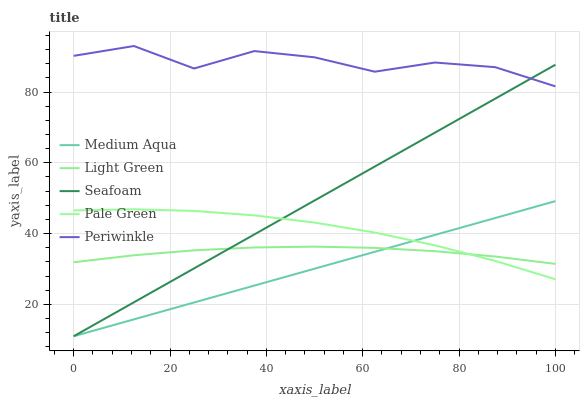Does Medium Aqua have the minimum area under the curve?
Answer yes or no. Yes. Does Periwinkle have the maximum area under the curve?
Answer yes or no. Yes. Does Pale Green have the minimum area under the curve?
Answer yes or no. No. Does Pale Green have the maximum area under the curve?
Answer yes or no. No. Is Seafoam the smoothest?
Answer yes or no. Yes. Is Periwinkle the roughest?
Answer yes or no. Yes. Is Pale Green the smoothest?
Answer yes or no. No. Is Pale Green the roughest?
Answer yes or no. No. Does Pale Green have the lowest value?
Answer yes or no. No. Does Periwinkle have the highest value?
Answer yes or no. Yes. Does Pale Green have the highest value?
Answer yes or no. No. Is Light Green less than Periwinkle?
Answer yes or no. Yes. Is Periwinkle greater than Light Green?
Answer yes or no. Yes. Does Seafoam intersect Periwinkle?
Answer yes or no. Yes. Is Seafoam less than Periwinkle?
Answer yes or no. No. Is Seafoam greater than Periwinkle?
Answer yes or no. No. Does Light Green intersect Periwinkle?
Answer yes or no. No. 